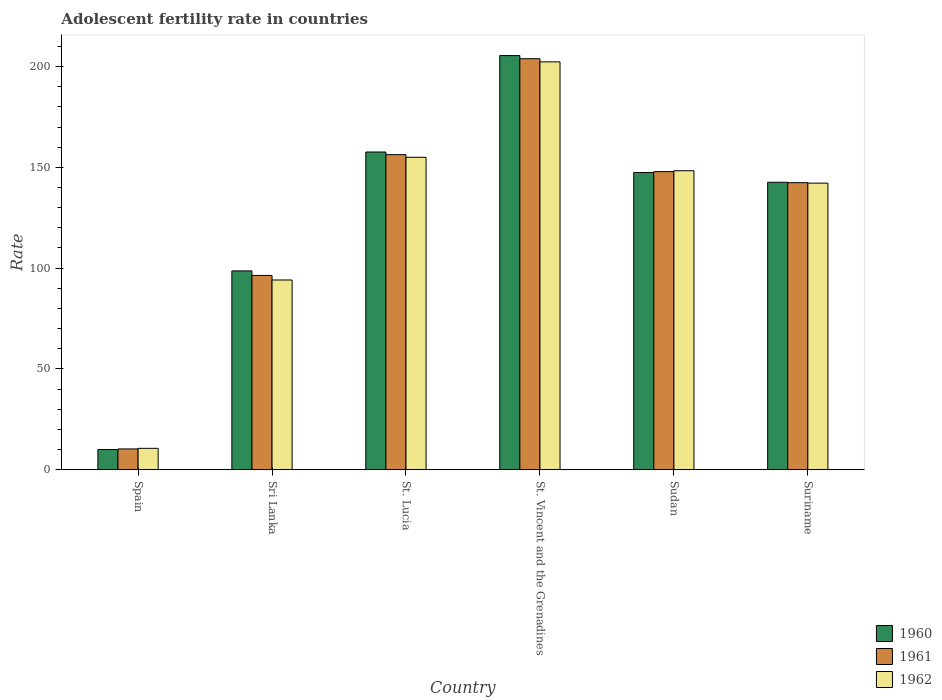What is the label of the 2nd group of bars from the left?
Offer a terse response. Sri Lanka. In how many cases, is the number of bars for a given country not equal to the number of legend labels?
Ensure brevity in your answer.  0. What is the adolescent fertility rate in 1961 in Spain?
Offer a very short reply. 10.35. Across all countries, what is the maximum adolescent fertility rate in 1961?
Ensure brevity in your answer.  203.87. Across all countries, what is the minimum adolescent fertility rate in 1960?
Make the answer very short. 10.06. In which country was the adolescent fertility rate in 1962 maximum?
Your answer should be compact. St. Vincent and the Grenadines. What is the total adolescent fertility rate in 1960 in the graph?
Make the answer very short. 761.75. What is the difference between the adolescent fertility rate in 1961 in St. Lucia and that in Sudan?
Offer a very short reply. 8.42. What is the difference between the adolescent fertility rate in 1960 in Sri Lanka and the adolescent fertility rate in 1962 in Sudan?
Offer a terse response. -49.67. What is the average adolescent fertility rate in 1960 per country?
Provide a short and direct response. 126.96. What is the difference between the adolescent fertility rate of/in 1962 and adolescent fertility rate of/in 1961 in Suriname?
Your response must be concise. -0.22. What is the ratio of the adolescent fertility rate in 1962 in Spain to that in Suriname?
Provide a short and direct response. 0.07. Is the adolescent fertility rate in 1960 in Spain less than that in Suriname?
Give a very brief answer. Yes. Is the difference between the adolescent fertility rate in 1962 in Spain and Sudan greater than the difference between the adolescent fertility rate in 1961 in Spain and Sudan?
Your response must be concise. No. What is the difference between the highest and the second highest adolescent fertility rate in 1961?
Your response must be concise. 47.57. What is the difference between the highest and the lowest adolescent fertility rate in 1962?
Your answer should be very brief. 191.67. In how many countries, is the adolescent fertility rate in 1962 greater than the average adolescent fertility rate in 1962 taken over all countries?
Provide a succinct answer. 4. How many bars are there?
Give a very brief answer. 18. How many countries are there in the graph?
Keep it short and to the point. 6. What is the difference between two consecutive major ticks on the Y-axis?
Provide a succinct answer. 50. Are the values on the major ticks of Y-axis written in scientific E-notation?
Ensure brevity in your answer.  No. Does the graph contain any zero values?
Make the answer very short. No. Does the graph contain grids?
Your answer should be compact. No. How are the legend labels stacked?
Offer a terse response. Vertical. What is the title of the graph?
Your answer should be very brief. Adolescent fertility rate in countries. Does "2007" appear as one of the legend labels in the graph?
Offer a terse response. No. What is the label or title of the Y-axis?
Provide a succinct answer. Rate. What is the Rate of 1960 in Spain?
Provide a succinct answer. 10.06. What is the Rate in 1961 in Spain?
Offer a terse response. 10.35. What is the Rate in 1962 in Spain?
Offer a very short reply. 10.64. What is the Rate in 1960 in Sri Lanka?
Your response must be concise. 98.64. What is the Rate of 1961 in Sri Lanka?
Your answer should be compact. 96.39. What is the Rate in 1962 in Sri Lanka?
Offer a very short reply. 94.13. What is the Rate of 1960 in St. Lucia?
Provide a short and direct response. 157.6. What is the Rate of 1961 in St. Lucia?
Give a very brief answer. 156.29. What is the Rate in 1962 in St. Lucia?
Your answer should be very brief. 154.99. What is the Rate in 1960 in St. Vincent and the Grenadines?
Provide a succinct answer. 205.42. What is the Rate in 1961 in St. Vincent and the Grenadines?
Provide a succinct answer. 203.87. What is the Rate in 1962 in St. Vincent and the Grenadines?
Ensure brevity in your answer.  202.32. What is the Rate in 1960 in Sudan?
Provide a succinct answer. 147.43. What is the Rate in 1961 in Sudan?
Your answer should be very brief. 147.87. What is the Rate of 1962 in Sudan?
Your answer should be compact. 148.31. What is the Rate of 1960 in Suriname?
Offer a terse response. 142.6. What is the Rate of 1961 in Suriname?
Provide a short and direct response. 142.38. What is the Rate of 1962 in Suriname?
Give a very brief answer. 142.17. Across all countries, what is the maximum Rate in 1960?
Provide a succinct answer. 205.42. Across all countries, what is the maximum Rate in 1961?
Give a very brief answer. 203.87. Across all countries, what is the maximum Rate in 1962?
Provide a short and direct response. 202.32. Across all countries, what is the minimum Rate in 1960?
Your answer should be compact. 10.06. Across all countries, what is the minimum Rate of 1961?
Your answer should be compact. 10.35. Across all countries, what is the minimum Rate in 1962?
Provide a short and direct response. 10.64. What is the total Rate of 1960 in the graph?
Give a very brief answer. 761.75. What is the total Rate of 1961 in the graph?
Your answer should be very brief. 757.15. What is the total Rate of 1962 in the graph?
Make the answer very short. 752.55. What is the difference between the Rate in 1960 in Spain and that in Sri Lanka?
Ensure brevity in your answer.  -88.59. What is the difference between the Rate in 1961 in Spain and that in Sri Lanka?
Ensure brevity in your answer.  -86.04. What is the difference between the Rate of 1962 in Spain and that in Sri Lanka?
Keep it short and to the point. -83.49. What is the difference between the Rate of 1960 in Spain and that in St. Lucia?
Your answer should be very brief. -147.55. What is the difference between the Rate of 1961 in Spain and that in St. Lucia?
Give a very brief answer. -145.94. What is the difference between the Rate in 1962 in Spain and that in St. Lucia?
Ensure brevity in your answer.  -144.34. What is the difference between the Rate in 1960 in Spain and that in St. Vincent and the Grenadines?
Keep it short and to the point. -195.36. What is the difference between the Rate in 1961 in Spain and that in St. Vincent and the Grenadines?
Your response must be concise. -193.52. What is the difference between the Rate of 1962 in Spain and that in St. Vincent and the Grenadines?
Offer a very short reply. -191.67. What is the difference between the Rate in 1960 in Spain and that in Sudan?
Your response must be concise. -137.38. What is the difference between the Rate of 1961 in Spain and that in Sudan?
Make the answer very short. -137.52. What is the difference between the Rate in 1962 in Spain and that in Sudan?
Your answer should be compact. -137.67. What is the difference between the Rate in 1960 in Spain and that in Suriname?
Ensure brevity in your answer.  -132.54. What is the difference between the Rate of 1961 in Spain and that in Suriname?
Ensure brevity in your answer.  -132.03. What is the difference between the Rate of 1962 in Spain and that in Suriname?
Provide a succinct answer. -131.52. What is the difference between the Rate of 1960 in Sri Lanka and that in St. Lucia?
Your response must be concise. -58.96. What is the difference between the Rate of 1961 in Sri Lanka and that in St. Lucia?
Your answer should be very brief. -59.91. What is the difference between the Rate in 1962 in Sri Lanka and that in St. Lucia?
Make the answer very short. -60.85. What is the difference between the Rate in 1960 in Sri Lanka and that in St. Vincent and the Grenadines?
Keep it short and to the point. -106.78. What is the difference between the Rate in 1961 in Sri Lanka and that in St. Vincent and the Grenadines?
Give a very brief answer. -107.48. What is the difference between the Rate of 1962 in Sri Lanka and that in St. Vincent and the Grenadines?
Make the answer very short. -108.19. What is the difference between the Rate in 1960 in Sri Lanka and that in Sudan?
Keep it short and to the point. -48.79. What is the difference between the Rate of 1961 in Sri Lanka and that in Sudan?
Your response must be concise. -51.49. What is the difference between the Rate of 1962 in Sri Lanka and that in Sudan?
Give a very brief answer. -54.18. What is the difference between the Rate of 1960 in Sri Lanka and that in Suriname?
Ensure brevity in your answer.  -43.96. What is the difference between the Rate in 1961 in Sri Lanka and that in Suriname?
Your answer should be very brief. -46. What is the difference between the Rate of 1962 in Sri Lanka and that in Suriname?
Make the answer very short. -48.04. What is the difference between the Rate of 1960 in St. Lucia and that in St. Vincent and the Grenadines?
Offer a very short reply. -47.82. What is the difference between the Rate of 1961 in St. Lucia and that in St. Vincent and the Grenadines?
Give a very brief answer. -47.57. What is the difference between the Rate of 1962 in St. Lucia and that in St. Vincent and the Grenadines?
Your response must be concise. -47.33. What is the difference between the Rate in 1960 in St. Lucia and that in Sudan?
Provide a short and direct response. 10.17. What is the difference between the Rate of 1961 in St. Lucia and that in Sudan?
Your answer should be very brief. 8.42. What is the difference between the Rate in 1962 in St. Lucia and that in Sudan?
Your response must be concise. 6.67. What is the difference between the Rate in 1960 in St. Lucia and that in Suriname?
Your answer should be compact. 15. What is the difference between the Rate of 1961 in St. Lucia and that in Suriname?
Provide a short and direct response. 13.91. What is the difference between the Rate in 1962 in St. Lucia and that in Suriname?
Keep it short and to the point. 12.82. What is the difference between the Rate in 1960 in St. Vincent and the Grenadines and that in Sudan?
Keep it short and to the point. 57.99. What is the difference between the Rate of 1961 in St. Vincent and the Grenadines and that in Sudan?
Your answer should be compact. 56. What is the difference between the Rate in 1962 in St. Vincent and the Grenadines and that in Sudan?
Your response must be concise. 54.01. What is the difference between the Rate in 1960 in St. Vincent and the Grenadines and that in Suriname?
Your answer should be compact. 62.82. What is the difference between the Rate in 1961 in St. Vincent and the Grenadines and that in Suriname?
Give a very brief answer. 61.48. What is the difference between the Rate of 1962 in St. Vincent and the Grenadines and that in Suriname?
Make the answer very short. 60.15. What is the difference between the Rate in 1960 in Sudan and that in Suriname?
Your answer should be very brief. 4.83. What is the difference between the Rate of 1961 in Sudan and that in Suriname?
Offer a very short reply. 5.49. What is the difference between the Rate in 1962 in Sudan and that in Suriname?
Provide a short and direct response. 6.14. What is the difference between the Rate in 1960 in Spain and the Rate in 1961 in Sri Lanka?
Offer a terse response. -86.33. What is the difference between the Rate in 1960 in Spain and the Rate in 1962 in Sri Lanka?
Offer a very short reply. -84.07. What is the difference between the Rate in 1961 in Spain and the Rate in 1962 in Sri Lanka?
Your answer should be very brief. -83.78. What is the difference between the Rate in 1960 in Spain and the Rate in 1961 in St. Lucia?
Make the answer very short. -146.24. What is the difference between the Rate in 1960 in Spain and the Rate in 1962 in St. Lucia?
Your answer should be very brief. -144.93. What is the difference between the Rate in 1961 in Spain and the Rate in 1962 in St. Lucia?
Make the answer very short. -144.63. What is the difference between the Rate of 1960 in Spain and the Rate of 1961 in St. Vincent and the Grenadines?
Your response must be concise. -193.81. What is the difference between the Rate in 1960 in Spain and the Rate in 1962 in St. Vincent and the Grenadines?
Offer a terse response. -192.26. What is the difference between the Rate of 1961 in Spain and the Rate of 1962 in St. Vincent and the Grenadines?
Give a very brief answer. -191.97. What is the difference between the Rate of 1960 in Spain and the Rate of 1961 in Sudan?
Ensure brevity in your answer.  -137.82. What is the difference between the Rate of 1960 in Spain and the Rate of 1962 in Sudan?
Provide a succinct answer. -138.25. What is the difference between the Rate of 1961 in Spain and the Rate of 1962 in Sudan?
Give a very brief answer. -137.96. What is the difference between the Rate in 1960 in Spain and the Rate in 1961 in Suriname?
Ensure brevity in your answer.  -132.33. What is the difference between the Rate of 1960 in Spain and the Rate of 1962 in Suriname?
Your response must be concise. -132.11. What is the difference between the Rate in 1961 in Spain and the Rate in 1962 in Suriname?
Offer a terse response. -131.82. What is the difference between the Rate of 1960 in Sri Lanka and the Rate of 1961 in St. Lucia?
Provide a succinct answer. -57.65. What is the difference between the Rate in 1960 in Sri Lanka and the Rate in 1962 in St. Lucia?
Your answer should be compact. -56.34. What is the difference between the Rate of 1961 in Sri Lanka and the Rate of 1962 in St. Lucia?
Your response must be concise. -58.6. What is the difference between the Rate in 1960 in Sri Lanka and the Rate in 1961 in St. Vincent and the Grenadines?
Provide a short and direct response. -105.23. What is the difference between the Rate in 1960 in Sri Lanka and the Rate in 1962 in St. Vincent and the Grenadines?
Offer a terse response. -103.67. What is the difference between the Rate in 1961 in Sri Lanka and the Rate in 1962 in St. Vincent and the Grenadines?
Make the answer very short. -105.93. What is the difference between the Rate of 1960 in Sri Lanka and the Rate of 1961 in Sudan?
Provide a succinct answer. -49.23. What is the difference between the Rate of 1960 in Sri Lanka and the Rate of 1962 in Sudan?
Keep it short and to the point. -49.67. What is the difference between the Rate of 1961 in Sri Lanka and the Rate of 1962 in Sudan?
Provide a succinct answer. -51.93. What is the difference between the Rate of 1960 in Sri Lanka and the Rate of 1961 in Suriname?
Offer a very short reply. -43.74. What is the difference between the Rate of 1960 in Sri Lanka and the Rate of 1962 in Suriname?
Offer a terse response. -43.53. What is the difference between the Rate of 1961 in Sri Lanka and the Rate of 1962 in Suriname?
Provide a succinct answer. -45.78. What is the difference between the Rate of 1960 in St. Lucia and the Rate of 1961 in St. Vincent and the Grenadines?
Offer a very short reply. -46.27. What is the difference between the Rate of 1960 in St. Lucia and the Rate of 1962 in St. Vincent and the Grenadines?
Make the answer very short. -44.71. What is the difference between the Rate of 1961 in St. Lucia and the Rate of 1962 in St. Vincent and the Grenadines?
Your response must be concise. -46.02. What is the difference between the Rate in 1960 in St. Lucia and the Rate in 1961 in Sudan?
Offer a terse response. 9.73. What is the difference between the Rate of 1960 in St. Lucia and the Rate of 1962 in Sudan?
Offer a very short reply. 9.29. What is the difference between the Rate of 1961 in St. Lucia and the Rate of 1962 in Sudan?
Make the answer very short. 7.98. What is the difference between the Rate of 1960 in St. Lucia and the Rate of 1961 in Suriname?
Ensure brevity in your answer.  15.22. What is the difference between the Rate in 1960 in St. Lucia and the Rate in 1962 in Suriname?
Ensure brevity in your answer.  15.44. What is the difference between the Rate in 1961 in St. Lucia and the Rate in 1962 in Suriname?
Make the answer very short. 14.13. What is the difference between the Rate of 1960 in St. Vincent and the Grenadines and the Rate of 1961 in Sudan?
Ensure brevity in your answer.  57.55. What is the difference between the Rate in 1960 in St. Vincent and the Grenadines and the Rate in 1962 in Sudan?
Ensure brevity in your answer.  57.11. What is the difference between the Rate in 1961 in St. Vincent and the Grenadines and the Rate in 1962 in Sudan?
Make the answer very short. 55.56. What is the difference between the Rate of 1960 in St. Vincent and the Grenadines and the Rate of 1961 in Suriname?
Provide a succinct answer. 63.04. What is the difference between the Rate in 1960 in St. Vincent and the Grenadines and the Rate in 1962 in Suriname?
Provide a succinct answer. 63.25. What is the difference between the Rate of 1961 in St. Vincent and the Grenadines and the Rate of 1962 in Suriname?
Provide a succinct answer. 61.7. What is the difference between the Rate of 1960 in Sudan and the Rate of 1961 in Suriname?
Give a very brief answer. 5.05. What is the difference between the Rate in 1960 in Sudan and the Rate in 1962 in Suriname?
Your response must be concise. 5.26. What is the difference between the Rate of 1961 in Sudan and the Rate of 1962 in Suriname?
Provide a succinct answer. 5.7. What is the average Rate of 1960 per country?
Your answer should be very brief. 126.96. What is the average Rate of 1961 per country?
Offer a terse response. 126.19. What is the average Rate in 1962 per country?
Make the answer very short. 125.43. What is the difference between the Rate in 1960 and Rate in 1961 in Spain?
Make the answer very short. -0.29. What is the difference between the Rate in 1960 and Rate in 1962 in Spain?
Provide a short and direct response. -0.59. What is the difference between the Rate in 1961 and Rate in 1962 in Spain?
Offer a terse response. -0.29. What is the difference between the Rate of 1960 and Rate of 1961 in Sri Lanka?
Make the answer very short. 2.26. What is the difference between the Rate in 1960 and Rate in 1962 in Sri Lanka?
Ensure brevity in your answer.  4.51. What is the difference between the Rate of 1961 and Rate of 1962 in Sri Lanka?
Ensure brevity in your answer.  2.26. What is the difference between the Rate of 1960 and Rate of 1961 in St. Lucia?
Provide a short and direct response. 1.31. What is the difference between the Rate of 1960 and Rate of 1962 in St. Lucia?
Offer a very short reply. 2.62. What is the difference between the Rate of 1961 and Rate of 1962 in St. Lucia?
Your response must be concise. 1.31. What is the difference between the Rate in 1960 and Rate in 1961 in St. Vincent and the Grenadines?
Give a very brief answer. 1.55. What is the difference between the Rate of 1960 and Rate of 1962 in St. Vincent and the Grenadines?
Make the answer very short. 3.1. What is the difference between the Rate of 1961 and Rate of 1962 in St. Vincent and the Grenadines?
Keep it short and to the point. 1.55. What is the difference between the Rate in 1960 and Rate in 1961 in Sudan?
Ensure brevity in your answer.  -0.44. What is the difference between the Rate of 1960 and Rate of 1962 in Sudan?
Provide a short and direct response. -0.88. What is the difference between the Rate in 1961 and Rate in 1962 in Sudan?
Offer a very short reply. -0.44. What is the difference between the Rate of 1960 and Rate of 1961 in Suriname?
Ensure brevity in your answer.  0.22. What is the difference between the Rate in 1960 and Rate in 1962 in Suriname?
Your response must be concise. 0.43. What is the difference between the Rate in 1961 and Rate in 1962 in Suriname?
Your answer should be compact. 0.22. What is the ratio of the Rate in 1960 in Spain to that in Sri Lanka?
Your response must be concise. 0.1. What is the ratio of the Rate in 1961 in Spain to that in Sri Lanka?
Provide a succinct answer. 0.11. What is the ratio of the Rate in 1962 in Spain to that in Sri Lanka?
Offer a terse response. 0.11. What is the ratio of the Rate of 1960 in Spain to that in St. Lucia?
Offer a very short reply. 0.06. What is the ratio of the Rate in 1961 in Spain to that in St. Lucia?
Offer a terse response. 0.07. What is the ratio of the Rate in 1962 in Spain to that in St. Lucia?
Keep it short and to the point. 0.07. What is the ratio of the Rate in 1960 in Spain to that in St. Vincent and the Grenadines?
Keep it short and to the point. 0.05. What is the ratio of the Rate of 1961 in Spain to that in St. Vincent and the Grenadines?
Keep it short and to the point. 0.05. What is the ratio of the Rate in 1962 in Spain to that in St. Vincent and the Grenadines?
Your response must be concise. 0.05. What is the ratio of the Rate in 1960 in Spain to that in Sudan?
Your answer should be compact. 0.07. What is the ratio of the Rate in 1961 in Spain to that in Sudan?
Ensure brevity in your answer.  0.07. What is the ratio of the Rate of 1962 in Spain to that in Sudan?
Provide a short and direct response. 0.07. What is the ratio of the Rate in 1960 in Spain to that in Suriname?
Provide a short and direct response. 0.07. What is the ratio of the Rate of 1961 in Spain to that in Suriname?
Ensure brevity in your answer.  0.07. What is the ratio of the Rate in 1962 in Spain to that in Suriname?
Provide a short and direct response. 0.07. What is the ratio of the Rate in 1960 in Sri Lanka to that in St. Lucia?
Ensure brevity in your answer.  0.63. What is the ratio of the Rate of 1961 in Sri Lanka to that in St. Lucia?
Your answer should be very brief. 0.62. What is the ratio of the Rate of 1962 in Sri Lanka to that in St. Lucia?
Make the answer very short. 0.61. What is the ratio of the Rate of 1960 in Sri Lanka to that in St. Vincent and the Grenadines?
Offer a terse response. 0.48. What is the ratio of the Rate in 1961 in Sri Lanka to that in St. Vincent and the Grenadines?
Offer a terse response. 0.47. What is the ratio of the Rate of 1962 in Sri Lanka to that in St. Vincent and the Grenadines?
Offer a very short reply. 0.47. What is the ratio of the Rate in 1960 in Sri Lanka to that in Sudan?
Offer a terse response. 0.67. What is the ratio of the Rate of 1961 in Sri Lanka to that in Sudan?
Your answer should be compact. 0.65. What is the ratio of the Rate of 1962 in Sri Lanka to that in Sudan?
Your answer should be very brief. 0.63. What is the ratio of the Rate in 1960 in Sri Lanka to that in Suriname?
Your answer should be compact. 0.69. What is the ratio of the Rate of 1961 in Sri Lanka to that in Suriname?
Keep it short and to the point. 0.68. What is the ratio of the Rate of 1962 in Sri Lanka to that in Suriname?
Your answer should be very brief. 0.66. What is the ratio of the Rate of 1960 in St. Lucia to that in St. Vincent and the Grenadines?
Your answer should be compact. 0.77. What is the ratio of the Rate in 1961 in St. Lucia to that in St. Vincent and the Grenadines?
Your answer should be compact. 0.77. What is the ratio of the Rate in 1962 in St. Lucia to that in St. Vincent and the Grenadines?
Make the answer very short. 0.77. What is the ratio of the Rate in 1960 in St. Lucia to that in Sudan?
Give a very brief answer. 1.07. What is the ratio of the Rate of 1961 in St. Lucia to that in Sudan?
Your answer should be compact. 1.06. What is the ratio of the Rate in 1962 in St. Lucia to that in Sudan?
Provide a short and direct response. 1.04. What is the ratio of the Rate in 1960 in St. Lucia to that in Suriname?
Your response must be concise. 1.11. What is the ratio of the Rate of 1961 in St. Lucia to that in Suriname?
Offer a terse response. 1.1. What is the ratio of the Rate of 1962 in St. Lucia to that in Suriname?
Provide a succinct answer. 1.09. What is the ratio of the Rate in 1960 in St. Vincent and the Grenadines to that in Sudan?
Make the answer very short. 1.39. What is the ratio of the Rate of 1961 in St. Vincent and the Grenadines to that in Sudan?
Provide a short and direct response. 1.38. What is the ratio of the Rate of 1962 in St. Vincent and the Grenadines to that in Sudan?
Your answer should be very brief. 1.36. What is the ratio of the Rate of 1960 in St. Vincent and the Grenadines to that in Suriname?
Ensure brevity in your answer.  1.44. What is the ratio of the Rate in 1961 in St. Vincent and the Grenadines to that in Suriname?
Provide a succinct answer. 1.43. What is the ratio of the Rate of 1962 in St. Vincent and the Grenadines to that in Suriname?
Ensure brevity in your answer.  1.42. What is the ratio of the Rate in 1960 in Sudan to that in Suriname?
Ensure brevity in your answer.  1.03. What is the ratio of the Rate of 1962 in Sudan to that in Suriname?
Your response must be concise. 1.04. What is the difference between the highest and the second highest Rate of 1960?
Make the answer very short. 47.82. What is the difference between the highest and the second highest Rate in 1961?
Provide a succinct answer. 47.57. What is the difference between the highest and the second highest Rate in 1962?
Give a very brief answer. 47.33. What is the difference between the highest and the lowest Rate of 1960?
Offer a terse response. 195.36. What is the difference between the highest and the lowest Rate of 1961?
Ensure brevity in your answer.  193.52. What is the difference between the highest and the lowest Rate of 1962?
Give a very brief answer. 191.67. 